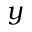<formula> <loc_0><loc_0><loc_500><loc_500>y</formula> 